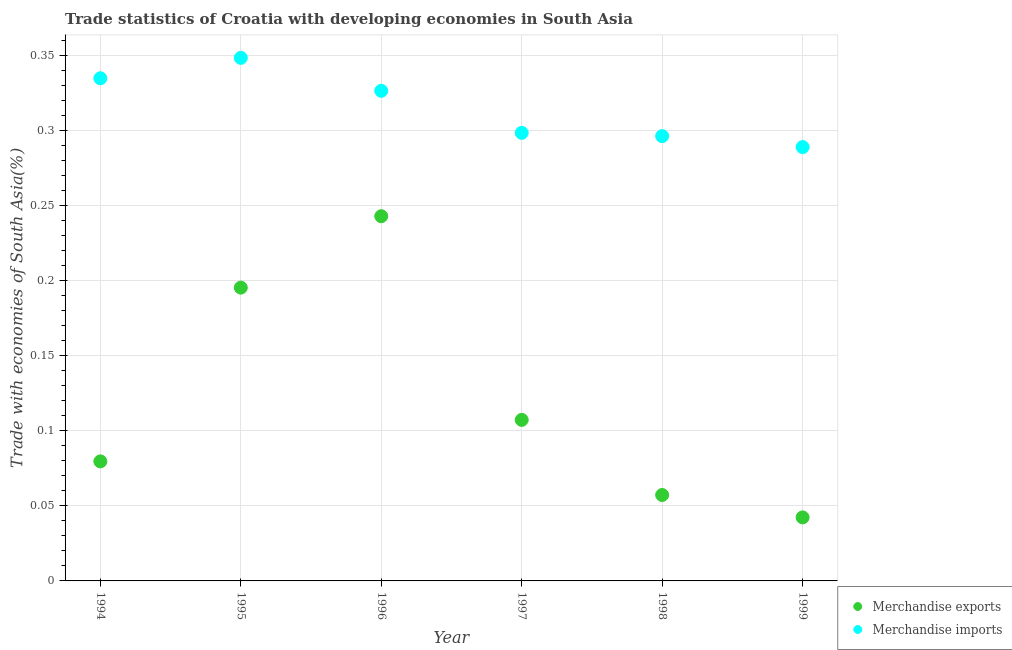Is the number of dotlines equal to the number of legend labels?
Keep it short and to the point. Yes. What is the merchandise exports in 1994?
Your response must be concise. 0.08. Across all years, what is the maximum merchandise imports?
Your answer should be compact. 0.35. Across all years, what is the minimum merchandise exports?
Make the answer very short. 0.04. In which year was the merchandise exports minimum?
Offer a very short reply. 1999. What is the total merchandise imports in the graph?
Your answer should be compact. 1.89. What is the difference between the merchandise imports in 1997 and that in 1999?
Ensure brevity in your answer.  0.01. What is the difference between the merchandise imports in 1994 and the merchandise exports in 1998?
Provide a short and direct response. 0.28. What is the average merchandise imports per year?
Make the answer very short. 0.32. In the year 1994, what is the difference between the merchandise exports and merchandise imports?
Provide a succinct answer. -0.26. What is the ratio of the merchandise imports in 1995 to that in 1999?
Provide a succinct answer. 1.21. Is the merchandise imports in 1994 less than that in 1995?
Your response must be concise. Yes. Is the difference between the merchandise imports in 1998 and 1999 greater than the difference between the merchandise exports in 1998 and 1999?
Ensure brevity in your answer.  No. What is the difference between the highest and the second highest merchandise imports?
Make the answer very short. 0.01. What is the difference between the highest and the lowest merchandise exports?
Offer a very short reply. 0.2. Is the merchandise exports strictly greater than the merchandise imports over the years?
Provide a succinct answer. No. Is the merchandise imports strictly less than the merchandise exports over the years?
Provide a succinct answer. No. How many dotlines are there?
Offer a terse response. 2. What is the difference between two consecutive major ticks on the Y-axis?
Your answer should be compact. 0.05. Are the values on the major ticks of Y-axis written in scientific E-notation?
Your answer should be compact. No. Does the graph contain any zero values?
Provide a short and direct response. No. Does the graph contain grids?
Provide a succinct answer. Yes. What is the title of the graph?
Offer a very short reply. Trade statistics of Croatia with developing economies in South Asia. What is the label or title of the Y-axis?
Offer a very short reply. Trade with economies of South Asia(%). What is the Trade with economies of South Asia(%) of Merchandise exports in 1994?
Provide a succinct answer. 0.08. What is the Trade with economies of South Asia(%) in Merchandise imports in 1994?
Provide a short and direct response. 0.34. What is the Trade with economies of South Asia(%) of Merchandise exports in 1995?
Keep it short and to the point. 0.2. What is the Trade with economies of South Asia(%) of Merchandise imports in 1995?
Ensure brevity in your answer.  0.35. What is the Trade with economies of South Asia(%) in Merchandise exports in 1996?
Give a very brief answer. 0.24. What is the Trade with economies of South Asia(%) in Merchandise imports in 1996?
Your response must be concise. 0.33. What is the Trade with economies of South Asia(%) in Merchandise exports in 1997?
Your answer should be compact. 0.11. What is the Trade with economies of South Asia(%) in Merchandise imports in 1997?
Ensure brevity in your answer.  0.3. What is the Trade with economies of South Asia(%) of Merchandise exports in 1998?
Offer a very short reply. 0.06. What is the Trade with economies of South Asia(%) of Merchandise imports in 1998?
Keep it short and to the point. 0.3. What is the Trade with economies of South Asia(%) in Merchandise exports in 1999?
Your answer should be very brief. 0.04. What is the Trade with economies of South Asia(%) in Merchandise imports in 1999?
Provide a short and direct response. 0.29. Across all years, what is the maximum Trade with economies of South Asia(%) of Merchandise exports?
Your response must be concise. 0.24. Across all years, what is the maximum Trade with economies of South Asia(%) of Merchandise imports?
Give a very brief answer. 0.35. Across all years, what is the minimum Trade with economies of South Asia(%) of Merchandise exports?
Ensure brevity in your answer.  0.04. Across all years, what is the minimum Trade with economies of South Asia(%) in Merchandise imports?
Make the answer very short. 0.29. What is the total Trade with economies of South Asia(%) in Merchandise exports in the graph?
Offer a terse response. 0.73. What is the total Trade with economies of South Asia(%) in Merchandise imports in the graph?
Ensure brevity in your answer.  1.89. What is the difference between the Trade with economies of South Asia(%) of Merchandise exports in 1994 and that in 1995?
Offer a terse response. -0.12. What is the difference between the Trade with economies of South Asia(%) in Merchandise imports in 1994 and that in 1995?
Offer a terse response. -0.01. What is the difference between the Trade with economies of South Asia(%) in Merchandise exports in 1994 and that in 1996?
Offer a very short reply. -0.16. What is the difference between the Trade with economies of South Asia(%) in Merchandise imports in 1994 and that in 1996?
Your response must be concise. 0.01. What is the difference between the Trade with economies of South Asia(%) of Merchandise exports in 1994 and that in 1997?
Make the answer very short. -0.03. What is the difference between the Trade with economies of South Asia(%) in Merchandise imports in 1994 and that in 1997?
Give a very brief answer. 0.04. What is the difference between the Trade with economies of South Asia(%) in Merchandise exports in 1994 and that in 1998?
Provide a short and direct response. 0.02. What is the difference between the Trade with economies of South Asia(%) in Merchandise imports in 1994 and that in 1998?
Make the answer very short. 0.04. What is the difference between the Trade with economies of South Asia(%) in Merchandise exports in 1994 and that in 1999?
Give a very brief answer. 0.04. What is the difference between the Trade with economies of South Asia(%) in Merchandise imports in 1994 and that in 1999?
Keep it short and to the point. 0.05. What is the difference between the Trade with economies of South Asia(%) of Merchandise exports in 1995 and that in 1996?
Keep it short and to the point. -0.05. What is the difference between the Trade with economies of South Asia(%) in Merchandise imports in 1995 and that in 1996?
Keep it short and to the point. 0.02. What is the difference between the Trade with economies of South Asia(%) of Merchandise exports in 1995 and that in 1997?
Your answer should be very brief. 0.09. What is the difference between the Trade with economies of South Asia(%) of Merchandise exports in 1995 and that in 1998?
Provide a short and direct response. 0.14. What is the difference between the Trade with economies of South Asia(%) of Merchandise imports in 1995 and that in 1998?
Your answer should be compact. 0.05. What is the difference between the Trade with economies of South Asia(%) in Merchandise exports in 1995 and that in 1999?
Give a very brief answer. 0.15. What is the difference between the Trade with economies of South Asia(%) of Merchandise imports in 1995 and that in 1999?
Your answer should be compact. 0.06. What is the difference between the Trade with economies of South Asia(%) of Merchandise exports in 1996 and that in 1997?
Offer a terse response. 0.14. What is the difference between the Trade with economies of South Asia(%) in Merchandise imports in 1996 and that in 1997?
Your response must be concise. 0.03. What is the difference between the Trade with economies of South Asia(%) of Merchandise exports in 1996 and that in 1998?
Make the answer very short. 0.19. What is the difference between the Trade with economies of South Asia(%) in Merchandise imports in 1996 and that in 1998?
Your answer should be compact. 0.03. What is the difference between the Trade with economies of South Asia(%) of Merchandise exports in 1996 and that in 1999?
Provide a short and direct response. 0.2. What is the difference between the Trade with economies of South Asia(%) in Merchandise imports in 1996 and that in 1999?
Your response must be concise. 0.04. What is the difference between the Trade with economies of South Asia(%) of Merchandise exports in 1997 and that in 1998?
Your answer should be very brief. 0.05. What is the difference between the Trade with economies of South Asia(%) of Merchandise imports in 1997 and that in 1998?
Your answer should be compact. 0. What is the difference between the Trade with economies of South Asia(%) in Merchandise exports in 1997 and that in 1999?
Ensure brevity in your answer.  0.07. What is the difference between the Trade with economies of South Asia(%) in Merchandise imports in 1997 and that in 1999?
Offer a terse response. 0.01. What is the difference between the Trade with economies of South Asia(%) in Merchandise exports in 1998 and that in 1999?
Ensure brevity in your answer.  0.01. What is the difference between the Trade with economies of South Asia(%) of Merchandise imports in 1998 and that in 1999?
Give a very brief answer. 0.01. What is the difference between the Trade with economies of South Asia(%) of Merchandise exports in 1994 and the Trade with economies of South Asia(%) of Merchandise imports in 1995?
Make the answer very short. -0.27. What is the difference between the Trade with economies of South Asia(%) of Merchandise exports in 1994 and the Trade with economies of South Asia(%) of Merchandise imports in 1996?
Offer a very short reply. -0.25. What is the difference between the Trade with economies of South Asia(%) of Merchandise exports in 1994 and the Trade with economies of South Asia(%) of Merchandise imports in 1997?
Offer a very short reply. -0.22. What is the difference between the Trade with economies of South Asia(%) in Merchandise exports in 1994 and the Trade with economies of South Asia(%) in Merchandise imports in 1998?
Offer a terse response. -0.22. What is the difference between the Trade with economies of South Asia(%) in Merchandise exports in 1994 and the Trade with economies of South Asia(%) in Merchandise imports in 1999?
Your response must be concise. -0.21. What is the difference between the Trade with economies of South Asia(%) of Merchandise exports in 1995 and the Trade with economies of South Asia(%) of Merchandise imports in 1996?
Your answer should be compact. -0.13. What is the difference between the Trade with economies of South Asia(%) in Merchandise exports in 1995 and the Trade with economies of South Asia(%) in Merchandise imports in 1997?
Offer a terse response. -0.1. What is the difference between the Trade with economies of South Asia(%) of Merchandise exports in 1995 and the Trade with economies of South Asia(%) of Merchandise imports in 1998?
Your response must be concise. -0.1. What is the difference between the Trade with economies of South Asia(%) in Merchandise exports in 1995 and the Trade with economies of South Asia(%) in Merchandise imports in 1999?
Keep it short and to the point. -0.09. What is the difference between the Trade with economies of South Asia(%) in Merchandise exports in 1996 and the Trade with economies of South Asia(%) in Merchandise imports in 1997?
Provide a short and direct response. -0.06. What is the difference between the Trade with economies of South Asia(%) of Merchandise exports in 1996 and the Trade with economies of South Asia(%) of Merchandise imports in 1998?
Your response must be concise. -0.05. What is the difference between the Trade with economies of South Asia(%) in Merchandise exports in 1996 and the Trade with economies of South Asia(%) in Merchandise imports in 1999?
Give a very brief answer. -0.05. What is the difference between the Trade with economies of South Asia(%) in Merchandise exports in 1997 and the Trade with economies of South Asia(%) in Merchandise imports in 1998?
Keep it short and to the point. -0.19. What is the difference between the Trade with economies of South Asia(%) of Merchandise exports in 1997 and the Trade with economies of South Asia(%) of Merchandise imports in 1999?
Your answer should be compact. -0.18. What is the difference between the Trade with economies of South Asia(%) in Merchandise exports in 1998 and the Trade with economies of South Asia(%) in Merchandise imports in 1999?
Keep it short and to the point. -0.23. What is the average Trade with economies of South Asia(%) of Merchandise exports per year?
Make the answer very short. 0.12. What is the average Trade with economies of South Asia(%) of Merchandise imports per year?
Your answer should be very brief. 0.32. In the year 1994, what is the difference between the Trade with economies of South Asia(%) in Merchandise exports and Trade with economies of South Asia(%) in Merchandise imports?
Provide a succinct answer. -0.26. In the year 1995, what is the difference between the Trade with economies of South Asia(%) in Merchandise exports and Trade with economies of South Asia(%) in Merchandise imports?
Provide a short and direct response. -0.15. In the year 1996, what is the difference between the Trade with economies of South Asia(%) of Merchandise exports and Trade with economies of South Asia(%) of Merchandise imports?
Offer a terse response. -0.08. In the year 1997, what is the difference between the Trade with economies of South Asia(%) in Merchandise exports and Trade with economies of South Asia(%) in Merchandise imports?
Your answer should be very brief. -0.19. In the year 1998, what is the difference between the Trade with economies of South Asia(%) in Merchandise exports and Trade with economies of South Asia(%) in Merchandise imports?
Keep it short and to the point. -0.24. In the year 1999, what is the difference between the Trade with economies of South Asia(%) of Merchandise exports and Trade with economies of South Asia(%) of Merchandise imports?
Give a very brief answer. -0.25. What is the ratio of the Trade with economies of South Asia(%) in Merchandise exports in 1994 to that in 1995?
Offer a very short reply. 0.41. What is the ratio of the Trade with economies of South Asia(%) of Merchandise imports in 1994 to that in 1995?
Your answer should be compact. 0.96. What is the ratio of the Trade with economies of South Asia(%) of Merchandise exports in 1994 to that in 1996?
Your answer should be compact. 0.33. What is the ratio of the Trade with economies of South Asia(%) in Merchandise imports in 1994 to that in 1996?
Provide a short and direct response. 1.03. What is the ratio of the Trade with economies of South Asia(%) of Merchandise exports in 1994 to that in 1997?
Your response must be concise. 0.74. What is the ratio of the Trade with economies of South Asia(%) of Merchandise imports in 1994 to that in 1997?
Make the answer very short. 1.12. What is the ratio of the Trade with economies of South Asia(%) of Merchandise exports in 1994 to that in 1998?
Give a very brief answer. 1.39. What is the ratio of the Trade with economies of South Asia(%) in Merchandise imports in 1994 to that in 1998?
Your answer should be compact. 1.13. What is the ratio of the Trade with economies of South Asia(%) of Merchandise exports in 1994 to that in 1999?
Give a very brief answer. 1.88. What is the ratio of the Trade with economies of South Asia(%) of Merchandise imports in 1994 to that in 1999?
Ensure brevity in your answer.  1.16. What is the ratio of the Trade with economies of South Asia(%) in Merchandise exports in 1995 to that in 1996?
Offer a very short reply. 0.8. What is the ratio of the Trade with economies of South Asia(%) of Merchandise imports in 1995 to that in 1996?
Offer a very short reply. 1.07. What is the ratio of the Trade with economies of South Asia(%) in Merchandise exports in 1995 to that in 1997?
Make the answer very short. 1.82. What is the ratio of the Trade with economies of South Asia(%) of Merchandise imports in 1995 to that in 1997?
Provide a succinct answer. 1.17. What is the ratio of the Trade with economies of South Asia(%) in Merchandise exports in 1995 to that in 1998?
Offer a terse response. 3.41. What is the ratio of the Trade with economies of South Asia(%) of Merchandise imports in 1995 to that in 1998?
Your response must be concise. 1.18. What is the ratio of the Trade with economies of South Asia(%) of Merchandise exports in 1995 to that in 1999?
Give a very brief answer. 4.62. What is the ratio of the Trade with economies of South Asia(%) in Merchandise imports in 1995 to that in 1999?
Provide a short and direct response. 1.21. What is the ratio of the Trade with economies of South Asia(%) in Merchandise exports in 1996 to that in 1997?
Your answer should be very brief. 2.26. What is the ratio of the Trade with economies of South Asia(%) of Merchandise imports in 1996 to that in 1997?
Provide a short and direct response. 1.09. What is the ratio of the Trade with economies of South Asia(%) of Merchandise exports in 1996 to that in 1998?
Your response must be concise. 4.24. What is the ratio of the Trade with economies of South Asia(%) of Merchandise imports in 1996 to that in 1998?
Keep it short and to the point. 1.1. What is the ratio of the Trade with economies of South Asia(%) of Merchandise exports in 1996 to that in 1999?
Your answer should be very brief. 5.74. What is the ratio of the Trade with economies of South Asia(%) in Merchandise imports in 1996 to that in 1999?
Make the answer very short. 1.13. What is the ratio of the Trade with economies of South Asia(%) in Merchandise exports in 1997 to that in 1998?
Provide a succinct answer. 1.87. What is the ratio of the Trade with economies of South Asia(%) of Merchandise imports in 1997 to that in 1998?
Your response must be concise. 1.01. What is the ratio of the Trade with economies of South Asia(%) of Merchandise exports in 1997 to that in 1999?
Your answer should be very brief. 2.53. What is the ratio of the Trade with economies of South Asia(%) of Merchandise imports in 1997 to that in 1999?
Your response must be concise. 1.03. What is the ratio of the Trade with economies of South Asia(%) of Merchandise exports in 1998 to that in 1999?
Make the answer very short. 1.35. What is the ratio of the Trade with economies of South Asia(%) in Merchandise imports in 1998 to that in 1999?
Make the answer very short. 1.03. What is the difference between the highest and the second highest Trade with economies of South Asia(%) of Merchandise exports?
Provide a short and direct response. 0.05. What is the difference between the highest and the second highest Trade with economies of South Asia(%) of Merchandise imports?
Ensure brevity in your answer.  0.01. What is the difference between the highest and the lowest Trade with economies of South Asia(%) in Merchandise exports?
Give a very brief answer. 0.2. What is the difference between the highest and the lowest Trade with economies of South Asia(%) of Merchandise imports?
Offer a terse response. 0.06. 